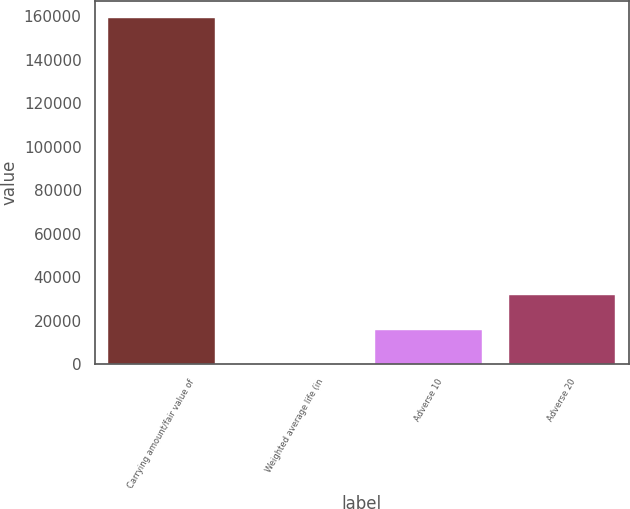Convert chart. <chart><loc_0><loc_0><loc_500><loc_500><bar_chart><fcel>Carrying amount/fair value of<fcel>Weighted average life (in<fcel>Adverse 10<fcel>Adverse 20<nl><fcel>159058<fcel>1.9<fcel>15907.5<fcel>31813.1<nl></chart> 